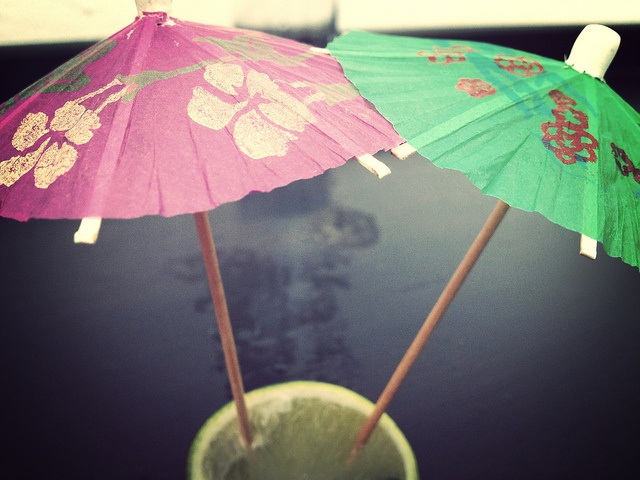Describe the objects in this image and their specific colors. I can see umbrella in lightyellow, lightpink, beige, violet, and tan tones and umbrella in lightyellow, lightgreen, and green tones in this image. 